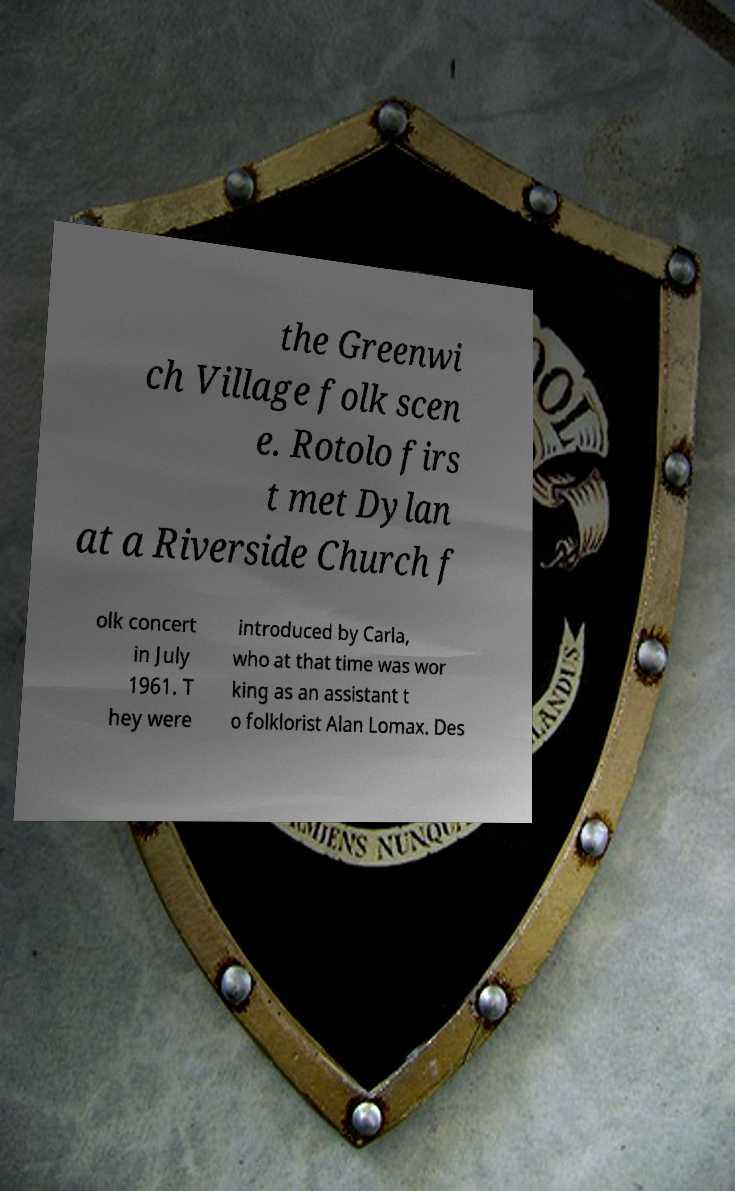Please identify and transcribe the text found in this image. the Greenwi ch Village folk scen e. Rotolo firs t met Dylan at a Riverside Church f olk concert in July 1961. T hey were introduced by Carla, who at that time was wor king as an assistant t o folklorist Alan Lomax. Des 